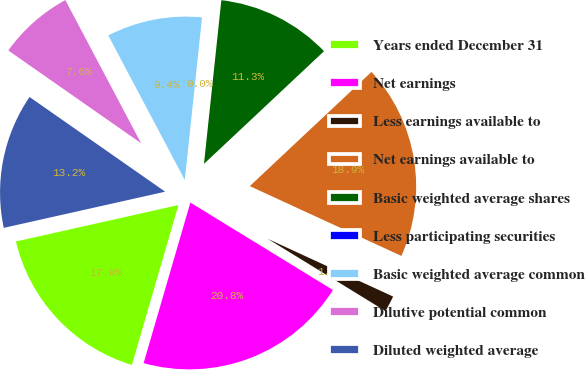Convert chart. <chart><loc_0><loc_0><loc_500><loc_500><pie_chart><fcel>Years ended December 31<fcel>Net earnings<fcel>Less earnings available to<fcel>Net earnings available to<fcel>Basic weighted average shares<fcel>Less participating securities<fcel>Basic weighted average common<fcel>Dilutive potential common<fcel>Diluted weighted average<nl><fcel>16.98%<fcel>20.75%<fcel>1.89%<fcel>18.86%<fcel>11.32%<fcel>0.0%<fcel>9.43%<fcel>7.55%<fcel>13.21%<nl></chart> 